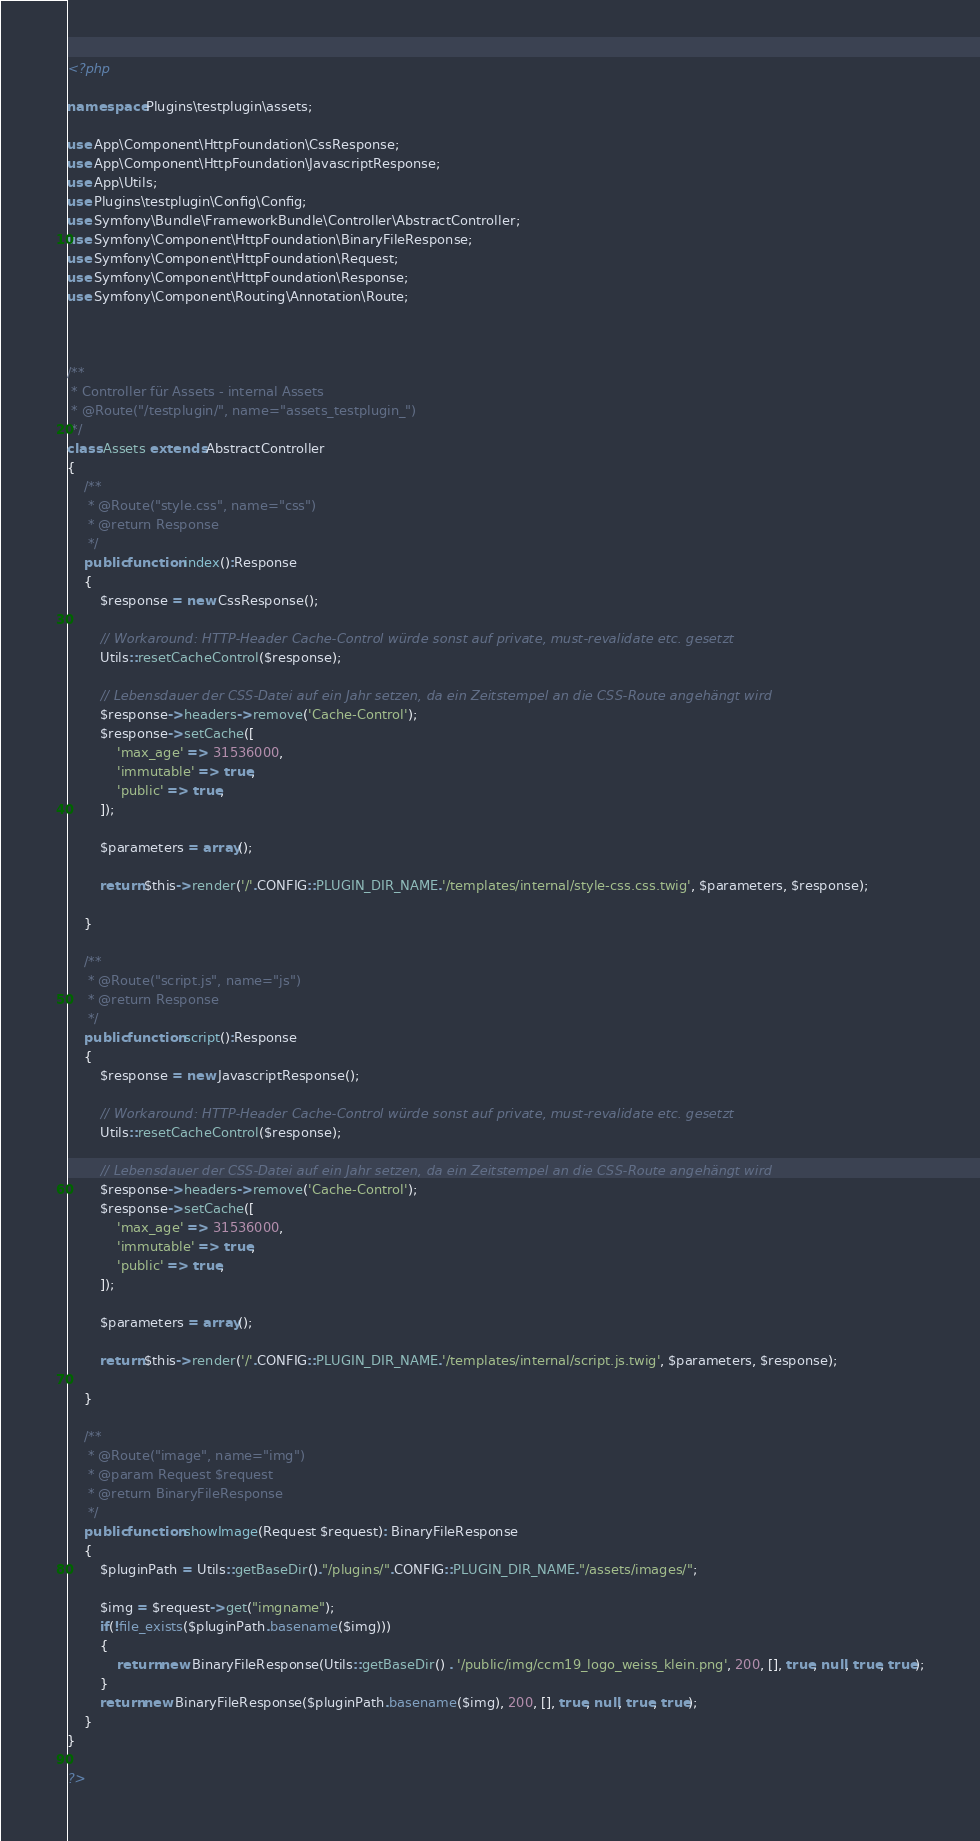<code> <loc_0><loc_0><loc_500><loc_500><_PHP_><?php

namespace Plugins\testplugin\assets;

use App\Component\HttpFoundation\CssResponse;
use App\Component\HttpFoundation\JavascriptResponse;
use App\Utils;
use Plugins\testplugin\Config\Config;
use Symfony\Bundle\FrameworkBundle\Controller\AbstractController;
use Symfony\Component\HttpFoundation\BinaryFileResponse;
use Symfony\Component\HttpFoundation\Request;
use Symfony\Component\HttpFoundation\Response;
use Symfony\Component\Routing\Annotation\Route;



/**
 * Controller für Assets - internal Assets
 * @Route("/testplugin/", name="assets_testplugin_")
 */
class Assets extends AbstractController
{
	/**
	 * @Route("style.css", name="css")
	 * @return Response
	 */
	public function index():Response
	{
		$response = new CssResponse();

		// Workaround: HTTP-Header Cache-Control würde sonst auf private, must-revalidate etc. gesetzt
		Utils::resetCacheControl($response);

		// Lebensdauer der CSS-Datei auf ein Jahr setzen, da ein Zeitstempel an die CSS-Route angehängt wird
		$response->headers->remove('Cache-Control');
		$response->setCache([
			'max_age' => 31536000,
			'immutable' => true,
			'public' => true,
		]);

		$parameters = array();

		return $this->render('/'.CONFIG::PLUGIN_DIR_NAME.'/templates/internal/style-css.css.twig', $parameters, $response);

	}

	/**
	 * @Route("script.js", name="js")
	 * @return Response
	 */
	public function script():Response
	{
		$response = new JavascriptResponse();

		// Workaround: HTTP-Header Cache-Control würde sonst auf private, must-revalidate etc. gesetzt
		Utils::resetCacheControl($response);

		// Lebensdauer der CSS-Datei auf ein Jahr setzen, da ein Zeitstempel an die CSS-Route angehängt wird
		$response->headers->remove('Cache-Control');
		$response->setCache([
			'max_age' => 31536000,
			'immutable' => true,
			'public' => true,
		]);

		$parameters = array();

		return $this->render('/'.CONFIG::PLUGIN_DIR_NAME.'/templates/internal/script.js.twig', $parameters, $response);

	}

	/**
	 * @Route("image", name="img")
	 * @param Request $request
	 * @return BinaryFileResponse
	 */
	public function showImage(Request $request): BinaryFileResponse
	{
		$pluginPath = Utils::getBaseDir()."/plugins/".CONFIG::PLUGIN_DIR_NAME."/assets/images/";

		$img = $request->get("imgname");
		if(!file_exists($pluginPath.basename($img)))
		{
			return new BinaryFileResponse(Utils::getBaseDir() . '/public/img/ccm19_logo_weiss_klein.png', 200, [], true, null, true, true);
		}
		return new BinaryFileResponse($pluginPath.basename($img), 200, [], true, null, true, true);
	}
}

?>
</code> 